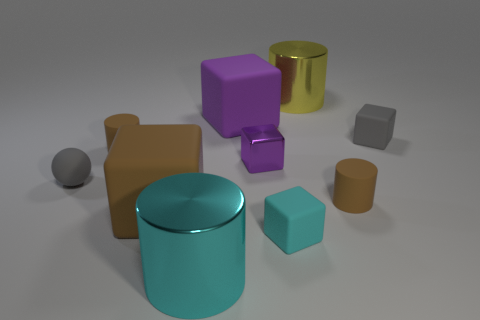Subtract all brown cubes. How many cubes are left? 4 Subtract 1 cubes. How many cubes are left? 4 Subtract all tiny gray matte cubes. How many cubes are left? 4 Subtract all green cubes. Subtract all purple cylinders. How many cubes are left? 5 Subtract all cylinders. How many objects are left? 6 Subtract all small gray rubber spheres. Subtract all big metallic cylinders. How many objects are left? 7 Add 3 cyan shiny cylinders. How many cyan shiny cylinders are left? 4 Add 7 small cyan matte objects. How many small cyan matte objects exist? 8 Subtract 0 purple balls. How many objects are left? 10 